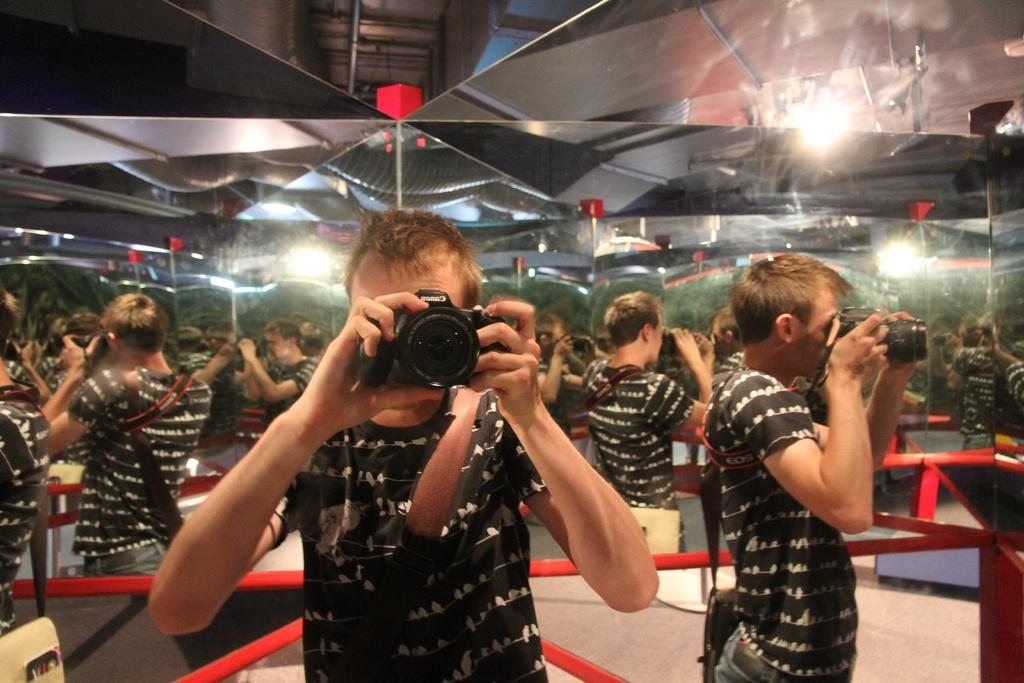What is the main subject of the image? There is a person in the image. What is the person holding in their hand? The person is holding a camera in their hand. What other detail can be seen in the image? There is a mirror image visible in a glass. Can you describe the setting of the image? The image is likely taken in a room. What type of attack is the person's father planning in the image? There is no mention of a father or an attack in the image. The image only shows a person holding a camera and a mirror image in a glass. 